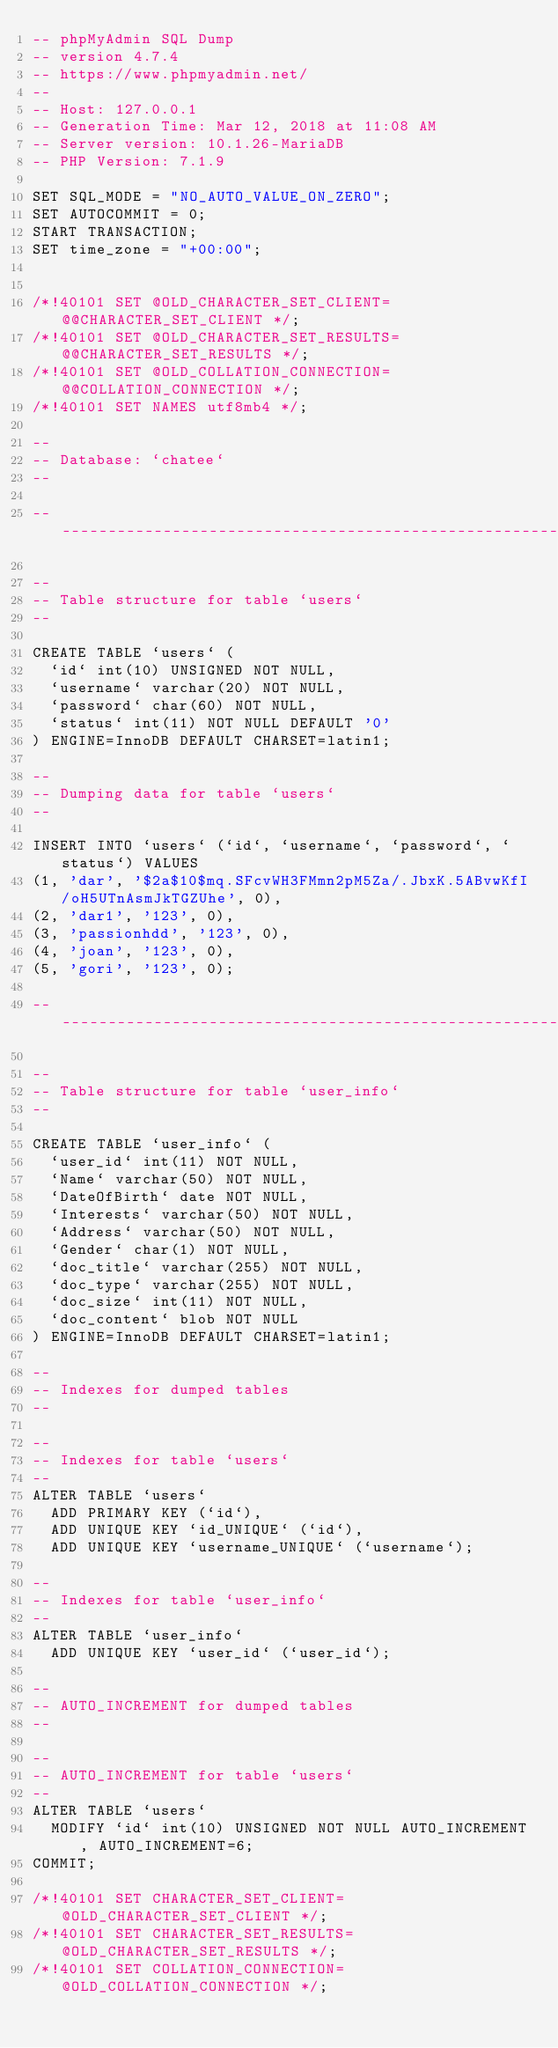<code> <loc_0><loc_0><loc_500><loc_500><_SQL_>-- phpMyAdmin SQL Dump
-- version 4.7.4
-- https://www.phpmyadmin.net/
--
-- Host: 127.0.0.1
-- Generation Time: Mar 12, 2018 at 11:08 AM
-- Server version: 10.1.26-MariaDB
-- PHP Version: 7.1.9

SET SQL_MODE = "NO_AUTO_VALUE_ON_ZERO";
SET AUTOCOMMIT = 0;
START TRANSACTION;
SET time_zone = "+00:00";


/*!40101 SET @OLD_CHARACTER_SET_CLIENT=@@CHARACTER_SET_CLIENT */;
/*!40101 SET @OLD_CHARACTER_SET_RESULTS=@@CHARACTER_SET_RESULTS */;
/*!40101 SET @OLD_COLLATION_CONNECTION=@@COLLATION_CONNECTION */;
/*!40101 SET NAMES utf8mb4 */;

--
-- Database: `chatee`
--

-- --------------------------------------------------------

--
-- Table structure for table `users`
--

CREATE TABLE `users` (
  `id` int(10) UNSIGNED NOT NULL,
  `username` varchar(20) NOT NULL,
  `password` char(60) NOT NULL,
  `status` int(11) NOT NULL DEFAULT '0'
) ENGINE=InnoDB DEFAULT CHARSET=latin1;

--
-- Dumping data for table `users`
--

INSERT INTO `users` (`id`, `username`, `password`, `status`) VALUES
(1, 'dar', '$2a$10$mq.SFcvWH3FMmn2pM5Za/.JbxK.5ABvwKfI/oH5UTnAsmJkTGZUhe', 0),
(2, 'dar1', '123', 0),
(3, 'passionhdd', '123', 0),
(4, 'joan', '123', 0),
(5, 'gori', '123', 0);

-- --------------------------------------------------------

--
-- Table structure for table `user_info`
--

CREATE TABLE `user_info` (
  `user_id` int(11) NOT NULL,
  `Name` varchar(50) NOT NULL,
  `DateOfBirth` date NOT NULL,
  `Interests` varchar(50) NOT NULL,
  `Address` varchar(50) NOT NULL,
  `Gender` char(1) NOT NULL,
  `doc_title` varchar(255) NOT NULL,
  `doc_type` varchar(255) NOT NULL,
  `doc_size` int(11) NOT NULL,
  `doc_content` blob NOT NULL
) ENGINE=InnoDB DEFAULT CHARSET=latin1;

--
-- Indexes for dumped tables
--

--
-- Indexes for table `users`
--
ALTER TABLE `users`
  ADD PRIMARY KEY (`id`),
  ADD UNIQUE KEY `id_UNIQUE` (`id`),
  ADD UNIQUE KEY `username_UNIQUE` (`username`);

--
-- Indexes for table `user_info`
--
ALTER TABLE `user_info`
  ADD UNIQUE KEY `user_id` (`user_id`);

--
-- AUTO_INCREMENT for dumped tables
--

--
-- AUTO_INCREMENT for table `users`
--
ALTER TABLE `users`
  MODIFY `id` int(10) UNSIGNED NOT NULL AUTO_INCREMENT, AUTO_INCREMENT=6;
COMMIT;

/*!40101 SET CHARACTER_SET_CLIENT=@OLD_CHARACTER_SET_CLIENT */;
/*!40101 SET CHARACTER_SET_RESULTS=@OLD_CHARACTER_SET_RESULTS */;
/*!40101 SET COLLATION_CONNECTION=@OLD_COLLATION_CONNECTION */;
</code> 